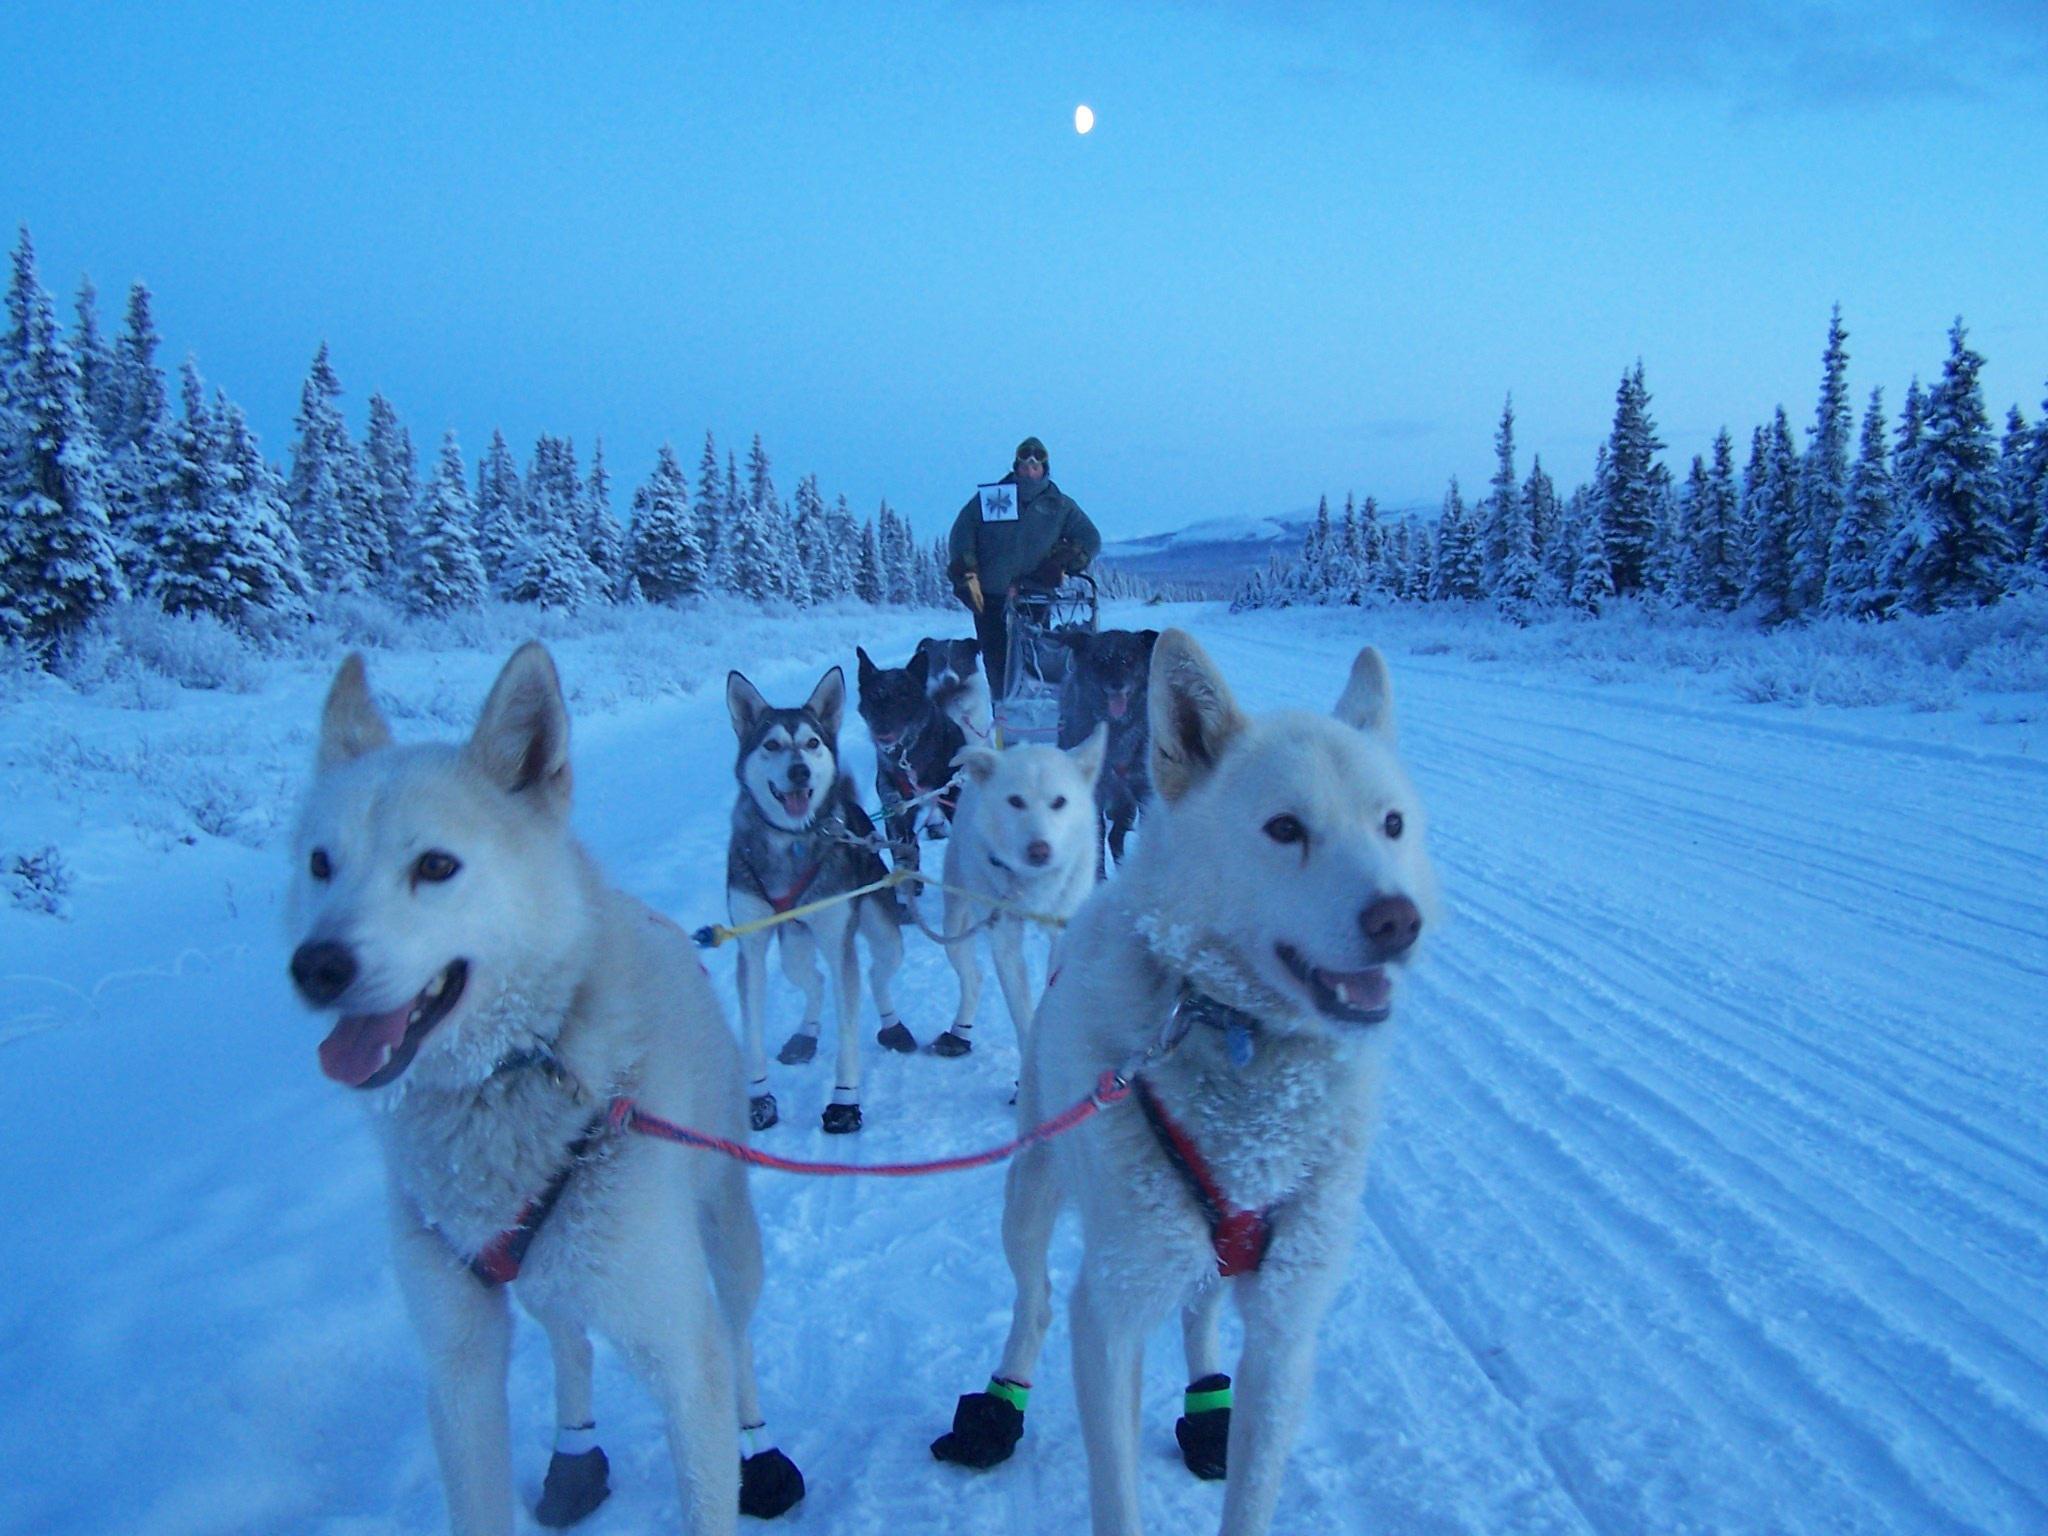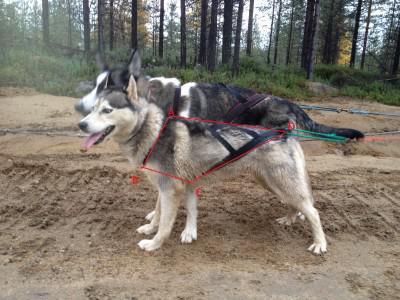The first image is the image on the left, the second image is the image on the right. For the images displayed, is the sentence "One photo contains a single dog." factually correct? Answer yes or no. No. The first image is the image on the left, the second image is the image on the right. Considering the images on both sides, is "An image shows just one dog, which is wearing a harness." valid? Answer yes or no. No. 